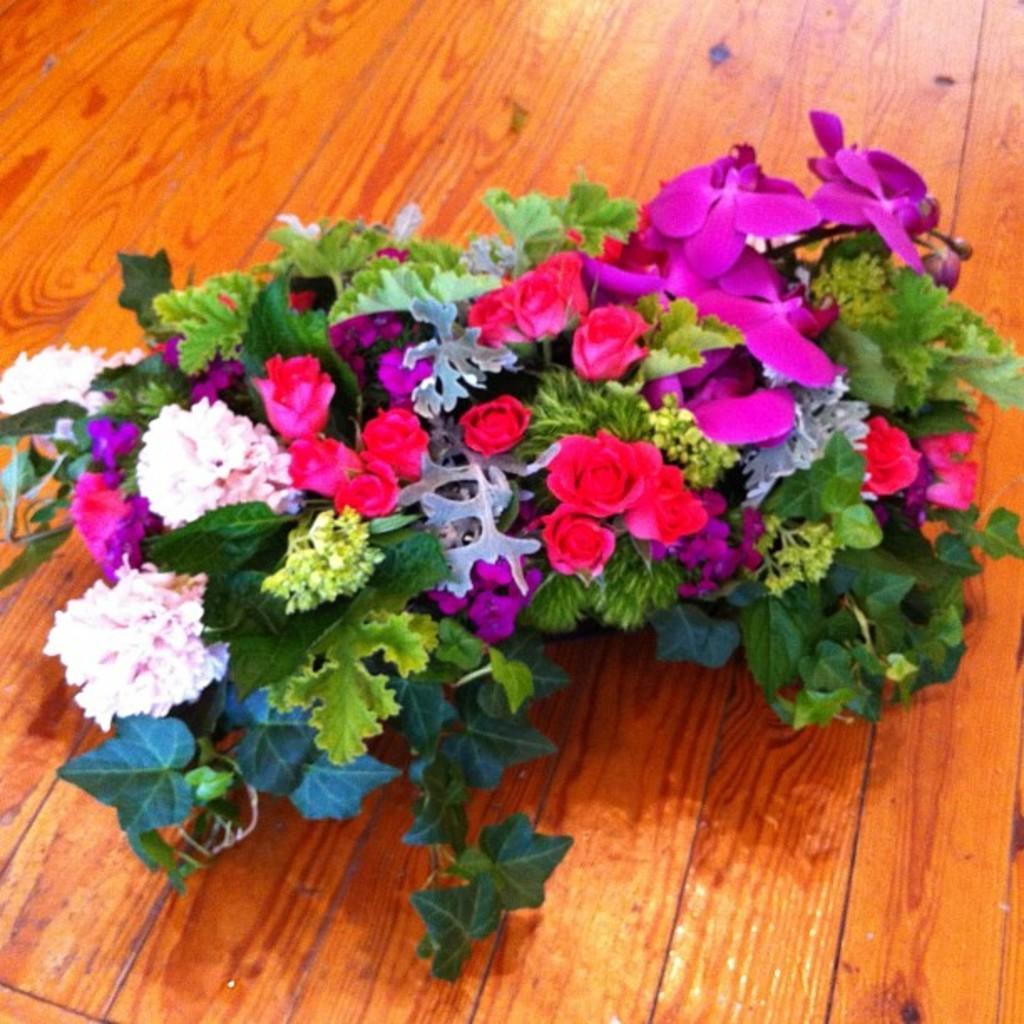Please provide a concise description of this image. In this picture I can see the brown color surface on which there are number of flowers which are of white, pink and red color. I can also see few leaves. 